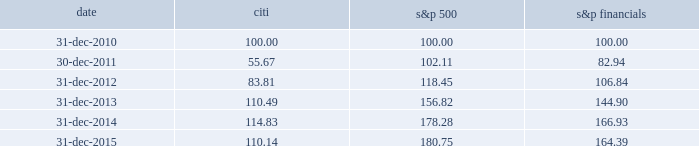Performance graph comparison of five-year cumulative total return the following graph and table compare the cumulative total return on citi 2019s common stock , which is listed on the nyse under the ticker symbol 201cc 201d and held by 81805 common stockholders of record as of january 31 , 2016 , with the cumulative total return of the s&p 500 index and the s&p financial index over the five-year period through december 31 , 2015 .
The graph and table assume that $ 100 was invested on december 31 , 2010 in citi 2019s common stock , the s&p 500 index and the s&p financial index , and that all dividends were reinvested .
Comparison of five-year cumulative total return for the years ended date citi s&p 500 financials .

What was the ratio of the growth of the cumulative total return for citi compared to s&p 500 in 2013? 
Rationale: in 2013 the cumulative total return for citi increased by $ .185 while the s&p 500 increased by $ 1
Computations: ((110.49 - 100) / (156.82 - 100))
Answer: 0.18462. 